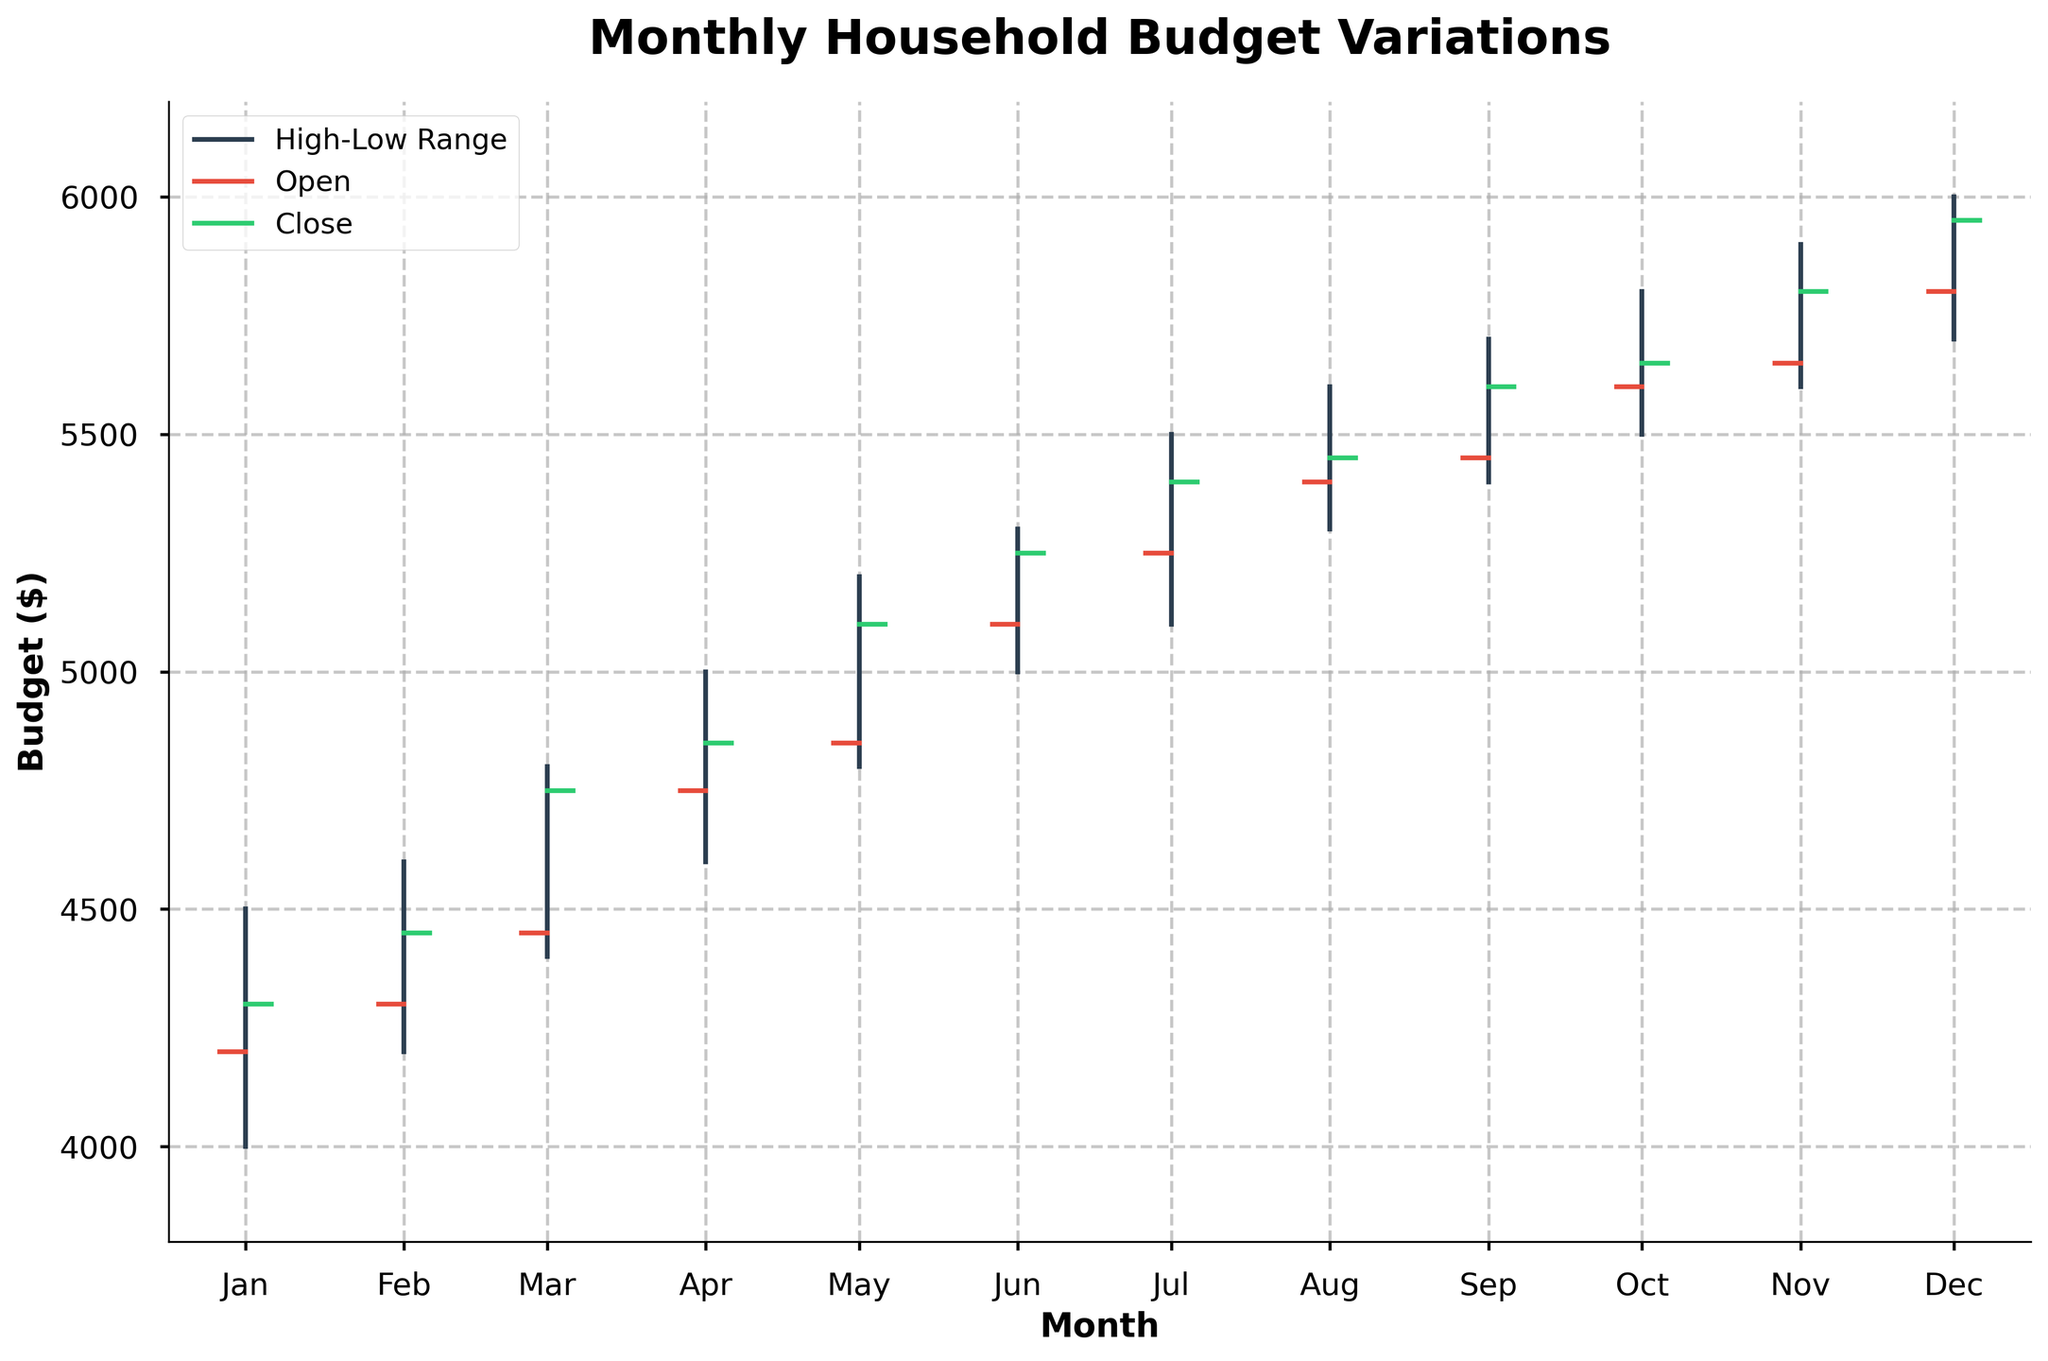What is the title of the plot? The title is located at the top of the chart and reads "Monthly Household Budget Variations," which indicates the main subject of the figure.
Answer: Monthly Household Budget Variations What do the colors on the horizontal ticks represent? The legend shows that the horizontal ticks in red represent the "Open" values, while the green horizontal ticks represent the "Close" values.
Answer: Red: Open, Green: Close What month had the highest budget close value? Look at the green horizontal tick positions for each month, December has the highest close value at $5950.
Answer: December In which month was the variance between high and low values the smallest? Examine the length of the vertical lines for each month. February has the smallest high-low range (4600 - 4200 = 400).
Answer: February Which two months had the highest increases in the close value compared to their open value? Calculate the increase from open to close for each month and compare them. January to February has an increase from 4300 to 4450 (+150), and February to March from 4450 to 4750 (+300) shows March and May have the highest increases.
Answer: March and May What is the range of budget in September? The range is the difference between the high and low values for September. It ranges from 5700 (high) to 5400 (low), thus the range is 5700 - 5400 = 300.
Answer: $300 Which months have a close value equal to the open value of the subsequent month? Check if the close value of one month matches the open value of the next month. This is true for January (close: 4300) and February (open: 4300), and for February (close: 4450) and March (open: 4450).
Answer: January and February What is the average closing budget for the entire year? Sum the close values of each month (4300 + 4450 + 4750 + 4850 + 5100 + 5250 + 5400 + 5450 + 5600 + 5650 + 5800 + 5950) and divide by 12 months; (64050 / 12) = 5343.33
Answer: $5343.33 Which month had the highest deviation between its open and close values? Calculate the absolute differences for each month between open and close values, May (5100 - 4850 = 250) has the highest deviation.
Answer: May How does the budget trend over the year? Check the general direction of the closing values month over month; it shows an overall increase from January to December.
Answer: Increasing 